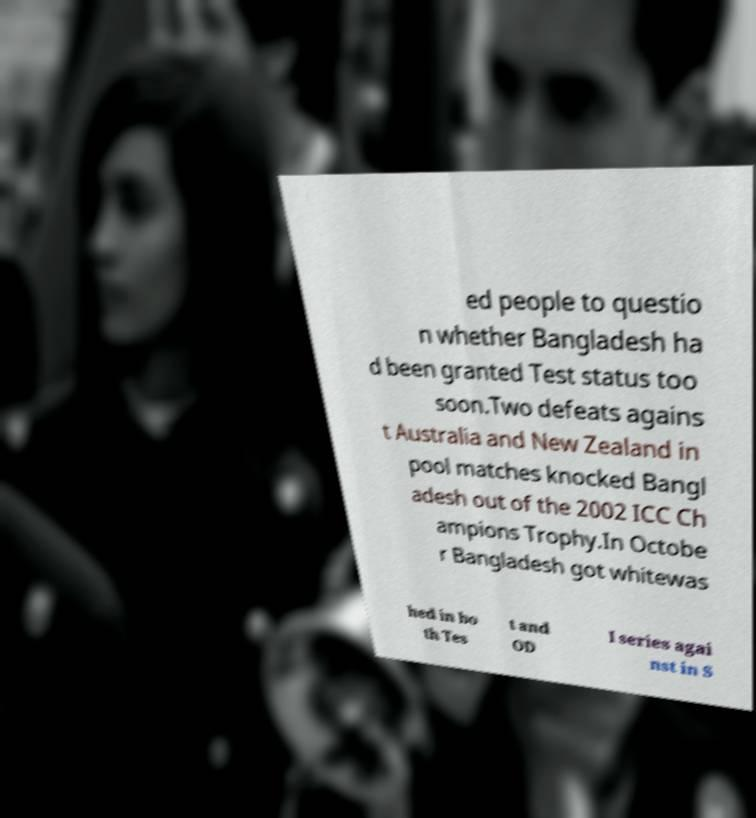Could you assist in decoding the text presented in this image and type it out clearly? ed people to questio n whether Bangladesh ha d been granted Test status too soon.Two defeats agains t Australia and New Zealand in pool matches knocked Bangl adesh out of the 2002 ICC Ch ampions Trophy.In Octobe r Bangladesh got whitewas hed in bo th Tes t and OD I series agai nst in S 